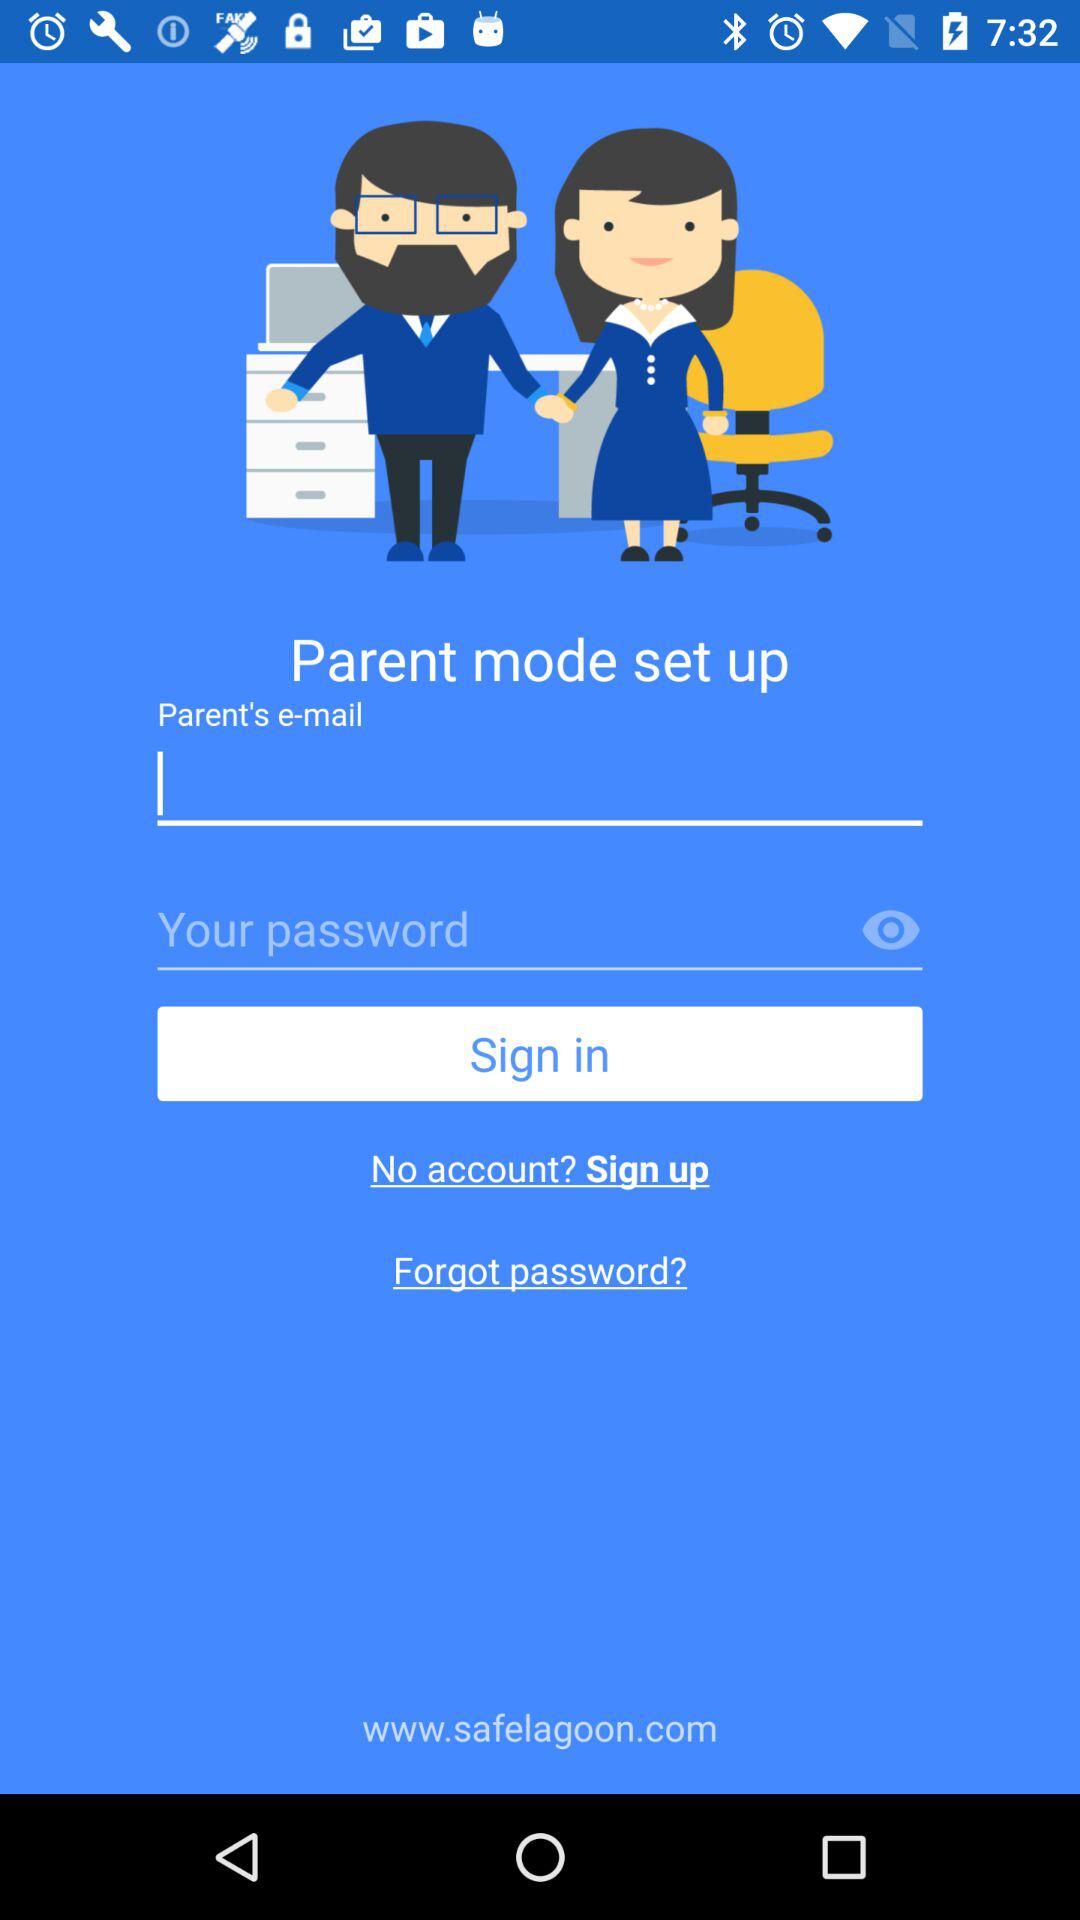What mode is being set? The mode that is being set is "Parent mode". 